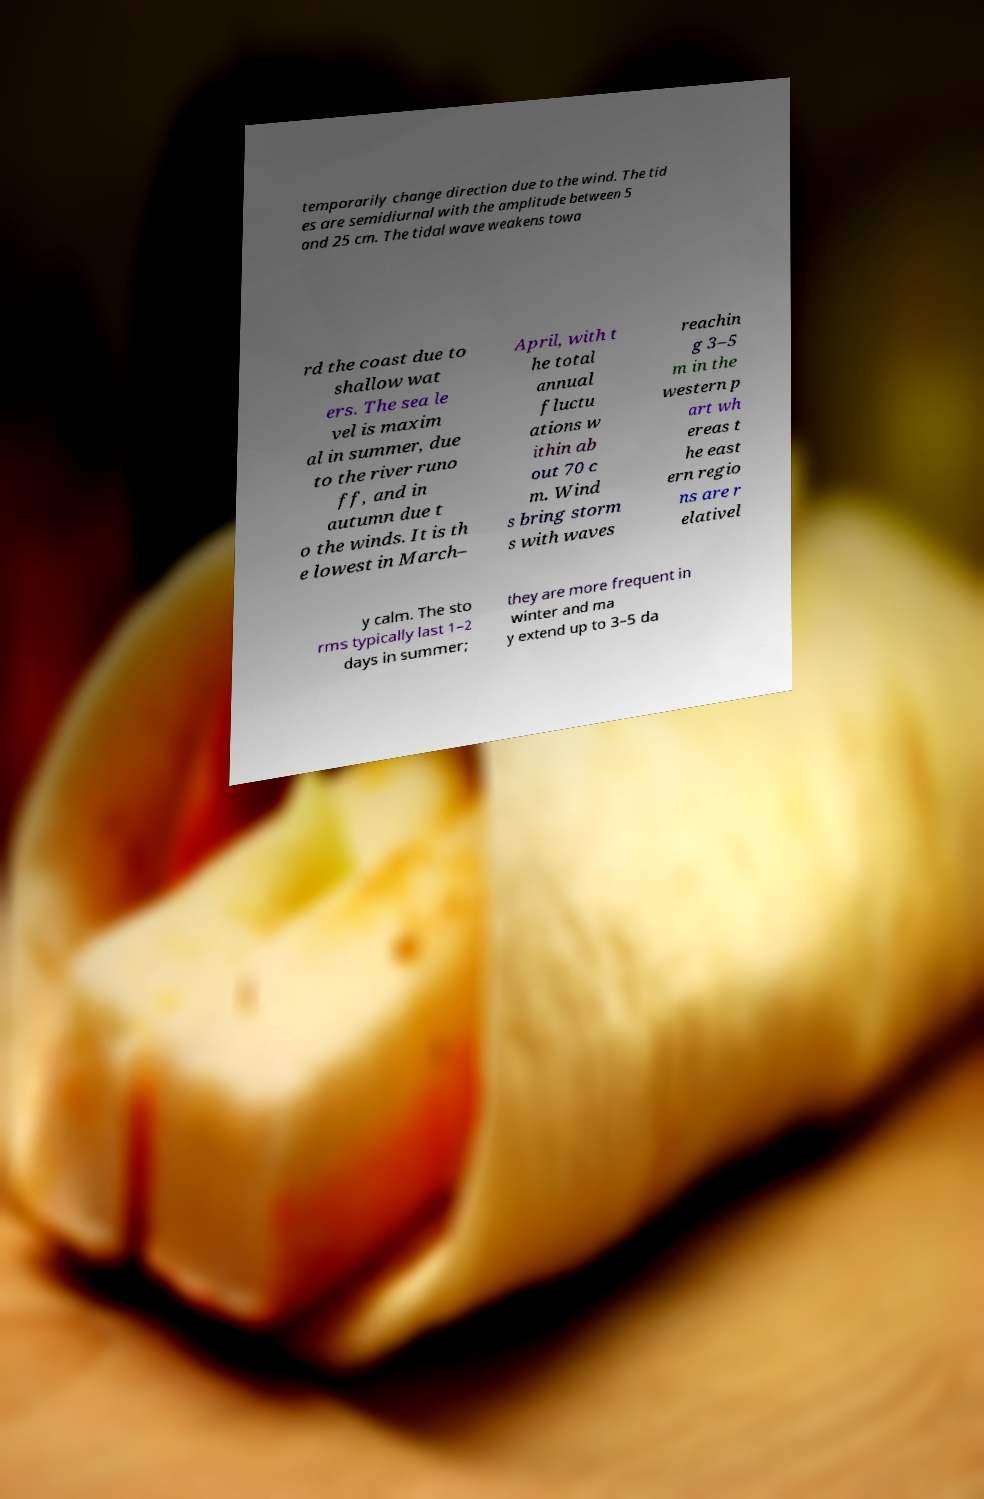Please identify and transcribe the text found in this image. temporarily change direction due to the wind. The tid es are semidiurnal with the amplitude between 5 and 25 cm. The tidal wave weakens towa rd the coast due to shallow wat ers. The sea le vel is maxim al in summer, due to the river runo ff, and in autumn due t o the winds. It is th e lowest in March– April, with t he total annual fluctu ations w ithin ab out 70 c m. Wind s bring storm s with waves reachin g 3–5 m in the western p art wh ereas t he east ern regio ns are r elativel y calm. The sto rms typically last 1–2 days in summer; they are more frequent in winter and ma y extend up to 3–5 da 